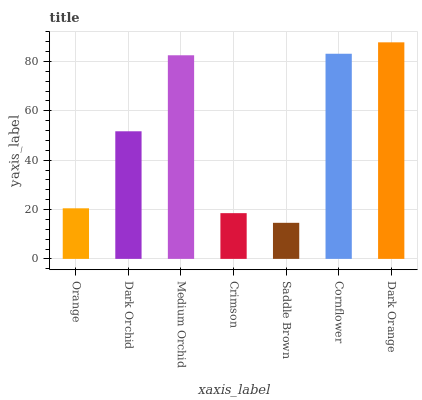Is Saddle Brown the minimum?
Answer yes or no. Yes. Is Dark Orange the maximum?
Answer yes or no. Yes. Is Dark Orchid the minimum?
Answer yes or no. No. Is Dark Orchid the maximum?
Answer yes or no. No. Is Dark Orchid greater than Orange?
Answer yes or no. Yes. Is Orange less than Dark Orchid?
Answer yes or no. Yes. Is Orange greater than Dark Orchid?
Answer yes or no. No. Is Dark Orchid less than Orange?
Answer yes or no. No. Is Dark Orchid the high median?
Answer yes or no. Yes. Is Dark Orchid the low median?
Answer yes or no. Yes. Is Dark Orange the high median?
Answer yes or no. No. Is Medium Orchid the low median?
Answer yes or no. No. 